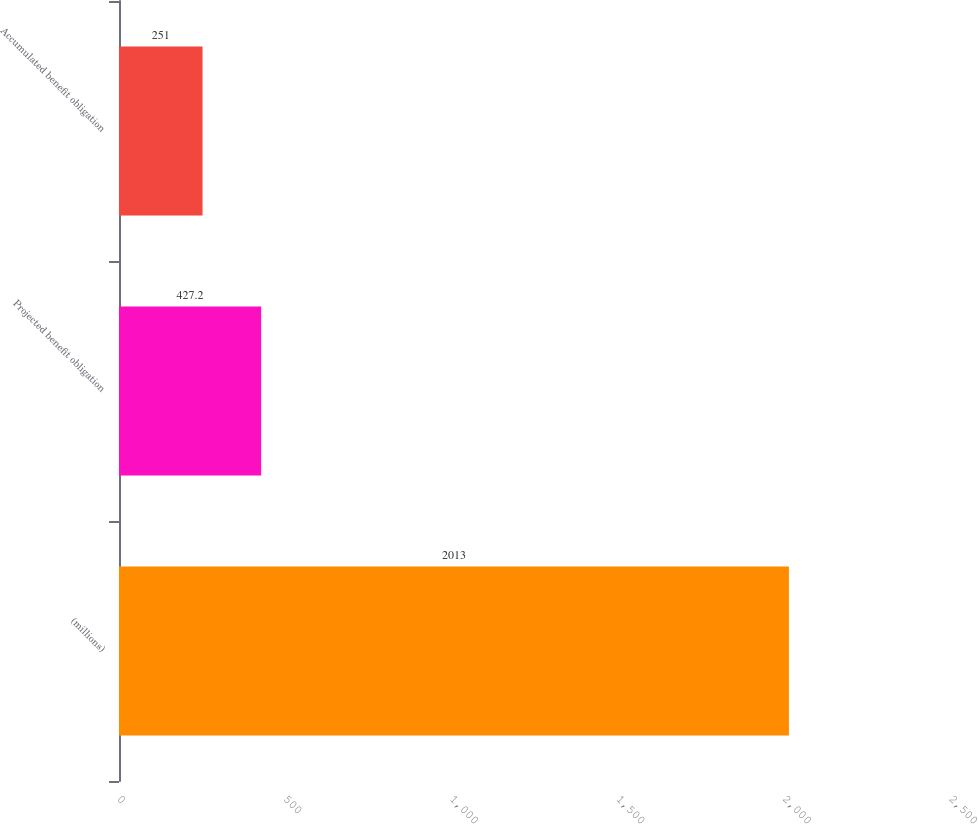Convert chart to OTSL. <chart><loc_0><loc_0><loc_500><loc_500><bar_chart><fcel>(millions)<fcel>Projected benefit obligation<fcel>Accumulated benefit obligation<nl><fcel>2013<fcel>427.2<fcel>251<nl></chart> 